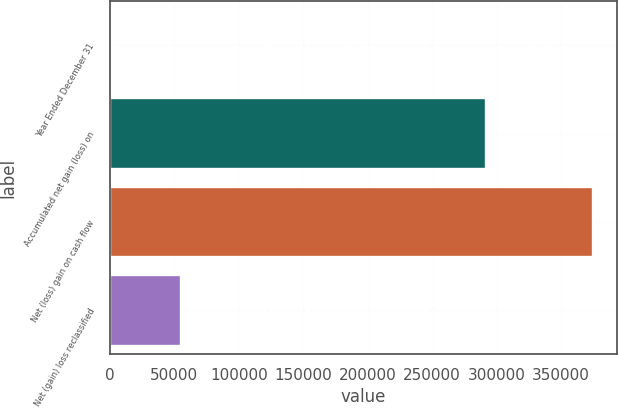Convert chart to OTSL. <chart><loc_0><loc_0><loc_500><loc_500><bar_chart><fcel>Year Ended December 31<fcel>Accumulated net gain (loss) on<fcel>Net (loss) gain on cash flow<fcel>Net (gain) loss reclassified<nl><fcel>2008<fcel>292192<fcel>374810<fcel>55241<nl></chart> 